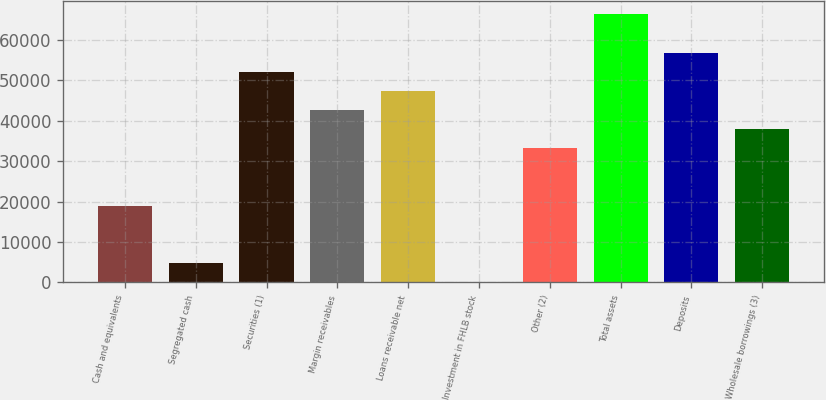Convert chart. <chart><loc_0><loc_0><loc_500><loc_500><bar_chart><fcel>Cash and equivalents<fcel>Segregated cash<fcel>Securities (1)<fcel>Margin receivables<fcel>Loans receivable net<fcel>Investment in FHLB stock<fcel>Other (2)<fcel>Total assets<fcel>Deposits<fcel>Wholesale borrowings (3)<nl><fcel>18995.1<fcel>4799.33<fcel>52118.6<fcel>42654.8<fcel>47386.7<fcel>67.4<fcel>33190.9<fcel>66314.4<fcel>56850.6<fcel>37922.8<nl></chart> 